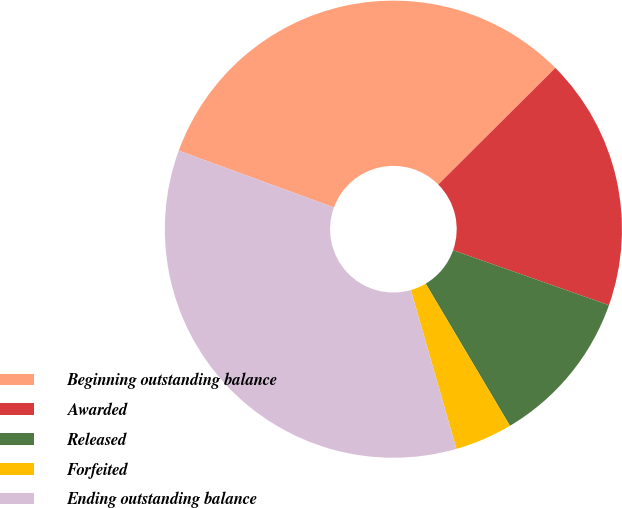Convert chart. <chart><loc_0><loc_0><loc_500><loc_500><pie_chart><fcel>Beginning outstanding balance<fcel>Awarded<fcel>Released<fcel>Forfeited<fcel>Ending outstanding balance<nl><fcel>31.95%<fcel>17.86%<fcel>11.09%<fcel>4.07%<fcel>35.03%<nl></chart> 